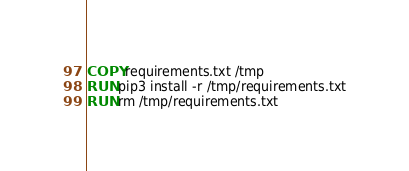<code> <loc_0><loc_0><loc_500><loc_500><_Dockerfile_>COPY requirements.txt /tmp
RUN pip3 install -r /tmp/requirements.txt
RUN rm /tmp/requirements.txt
</code> 